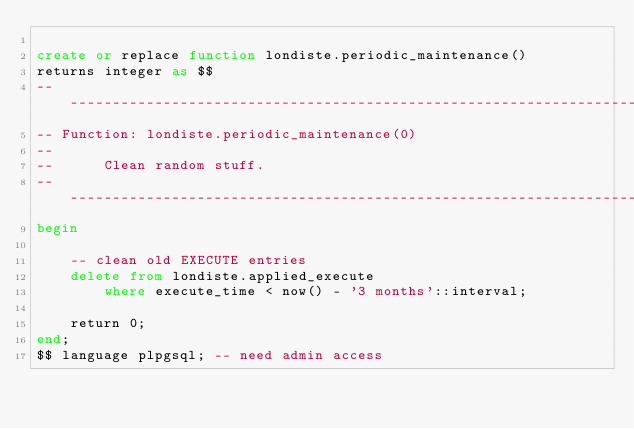Convert code to text. <code><loc_0><loc_0><loc_500><loc_500><_SQL_>
create or replace function londiste.periodic_maintenance()
returns integer as $$
-- ----------------------------------------------------------------------
-- Function: londiste.periodic_maintenance(0)
--
--      Clean random stuff.
-- ----------------------------------------------------------------------
begin

    -- clean old EXECUTE entries
    delete from londiste.applied_execute
        where execute_time < now() - '3 months'::interval;

    return 0;
end;
$$ language plpgsql; -- need admin access

</code> 